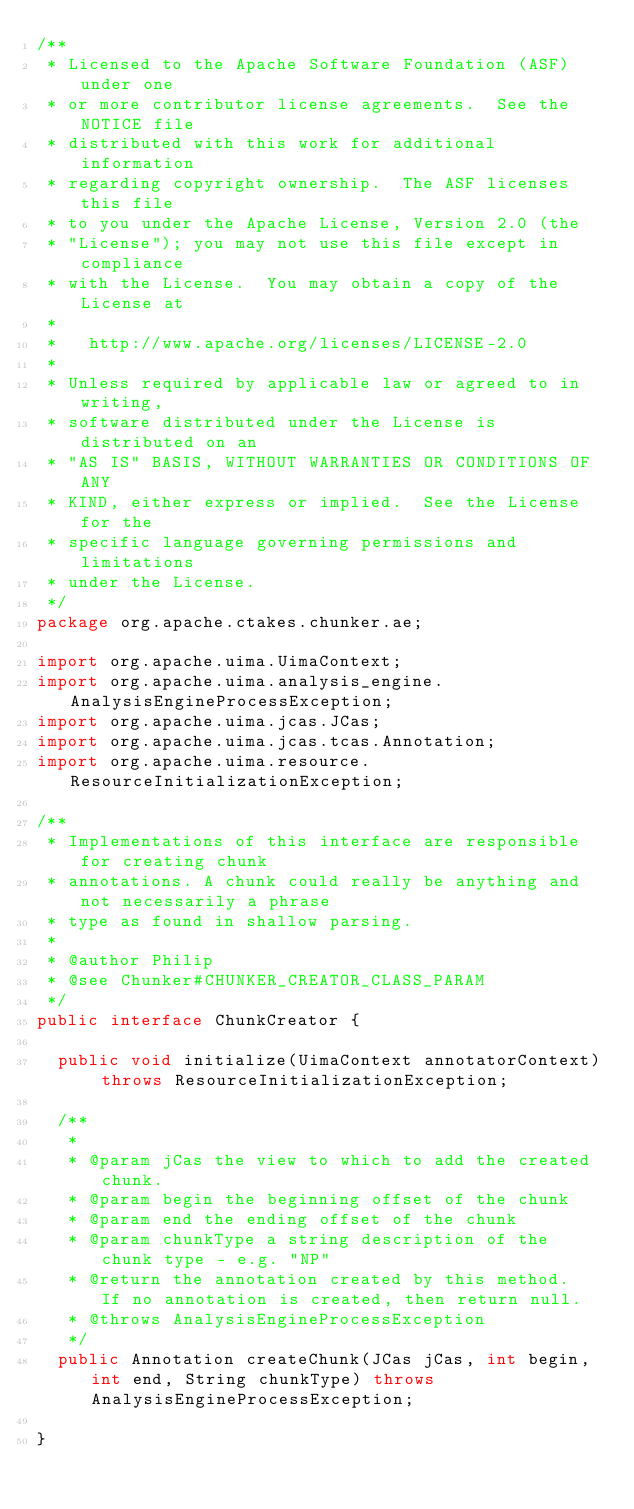Convert code to text. <code><loc_0><loc_0><loc_500><loc_500><_Java_>/**
 * Licensed to the Apache Software Foundation (ASF) under one
 * or more contributor license agreements.  See the NOTICE file
 * distributed with this work for additional information
 * regarding copyright ownership.  The ASF licenses this file
 * to you under the Apache License, Version 2.0 (the
 * "License"); you may not use this file except in compliance
 * with the License.  You may obtain a copy of the License at
 *
 *   http://www.apache.org/licenses/LICENSE-2.0
 *
 * Unless required by applicable law or agreed to in writing,
 * software distributed under the License is distributed on an
 * "AS IS" BASIS, WITHOUT WARRANTIES OR CONDITIONS OF ANY
 * KIND, either express or implied.  See the License for the
 * specific language governing permissions and limitations
 * under the License.
 */
package org.apache.ctakes.chunker.ae;

import org.apache.uima.UimaContext;
import org.apache.uima.analysis_engine.AnalysisEngineProcessException;
import org.apache.uima.jcas.JCas;
import org.apache.uima.jcas.tcas.Annotation;
import org.apache.uima.resource.ResourceInitializationException;

/**
 * Implementations of this interface are responsible for creating chunk
 * annotations. A chunk could really be anything and not necessarily a phrase
 * type as found in shallow parsing.
 * 
 * @author Philip
 * @see Chunker#CHUNKER_CREATOR_CLASS_PARAM
 */
public interface ChunkCreator {

	public void initialize(UimaContext annotatorContext) throws ResourceInitializationException;

	/**
	 * 
	 * @param jCas the view to which to add the created chunk.
	 * @param begin the beginning offset of the chunk
	 * @param end the ending offset of the chunk
	 * @param chunkType a string description of the chunk type - e.g. "NP"
	 * @return the annotation created by this method.  If no annotation is created, then return null.
	 * @throws AnalysisEngineProcessException
	 */
	public Annotation createChunk(JCas jCas, int begin, int end, String chunkType) throws AnalysisEngineProcessException;

}
</code> 